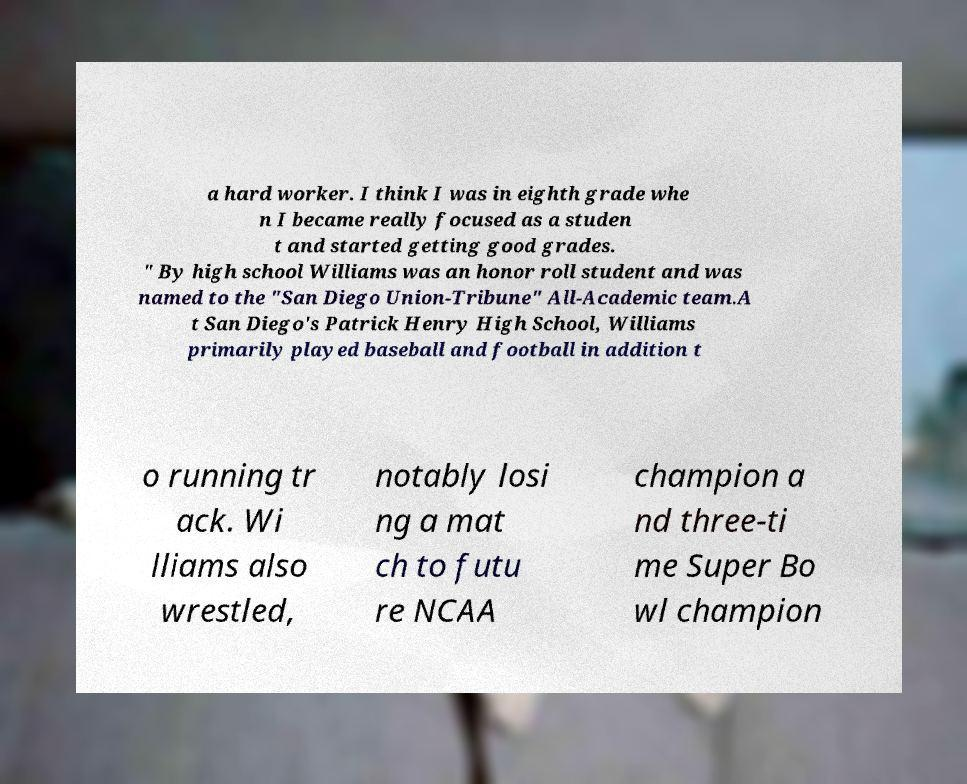Could you assist in decoding the text presented in this image and type it out clearly? a hard worker. I think I was in eighth grade whe n I became really focused as a studen t and started getting good grades. " By high school Williams was an honor roll student and was named to the "San Diego Union-Tribune" All-Academic team.A t San Diego's Patrick Henry High School, Williams primarily played baseball and football in addition t o running tr ack. Wi lliams also wrestled, notably losi ng a mat ch to futu re NCAA champion a nd three-ti me Super Bo wl champion 